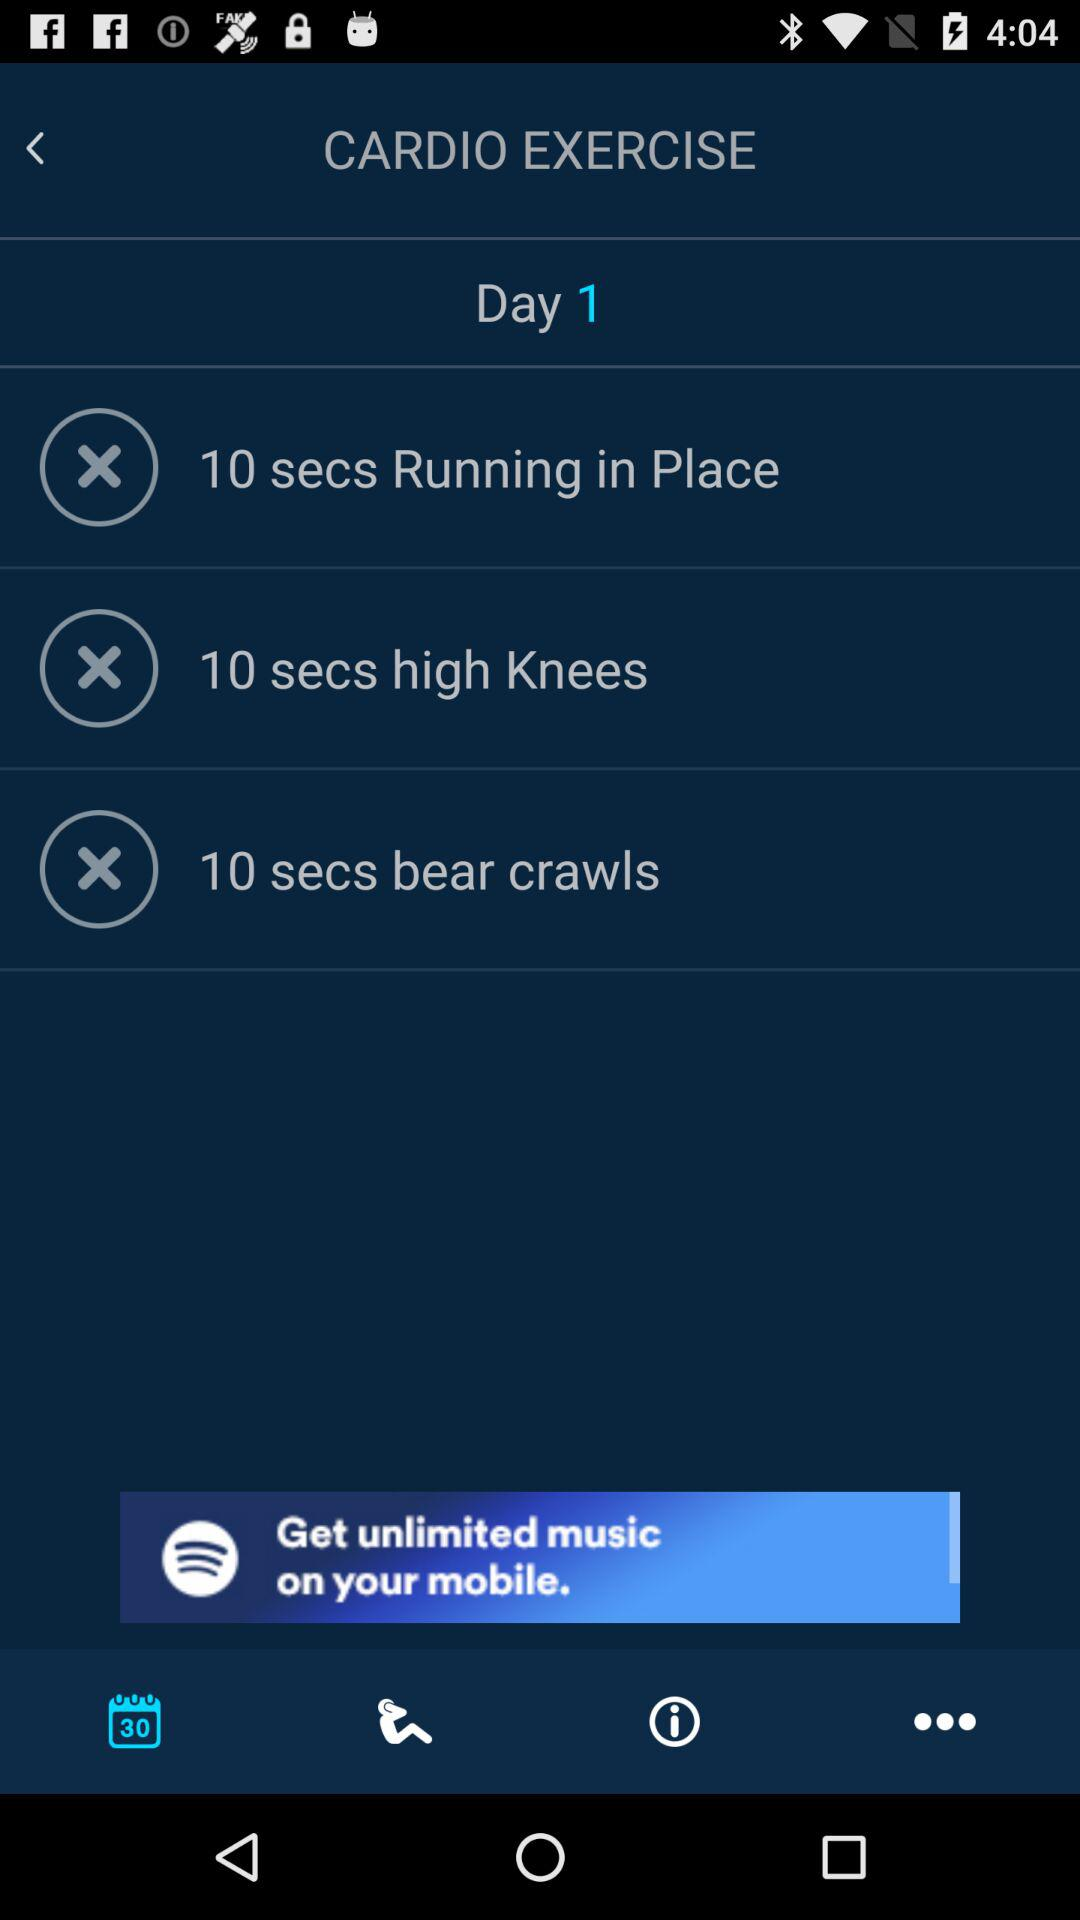What's the time duration for "Running in Place"? The time duration for "Running in Place" is 10 seconds. 